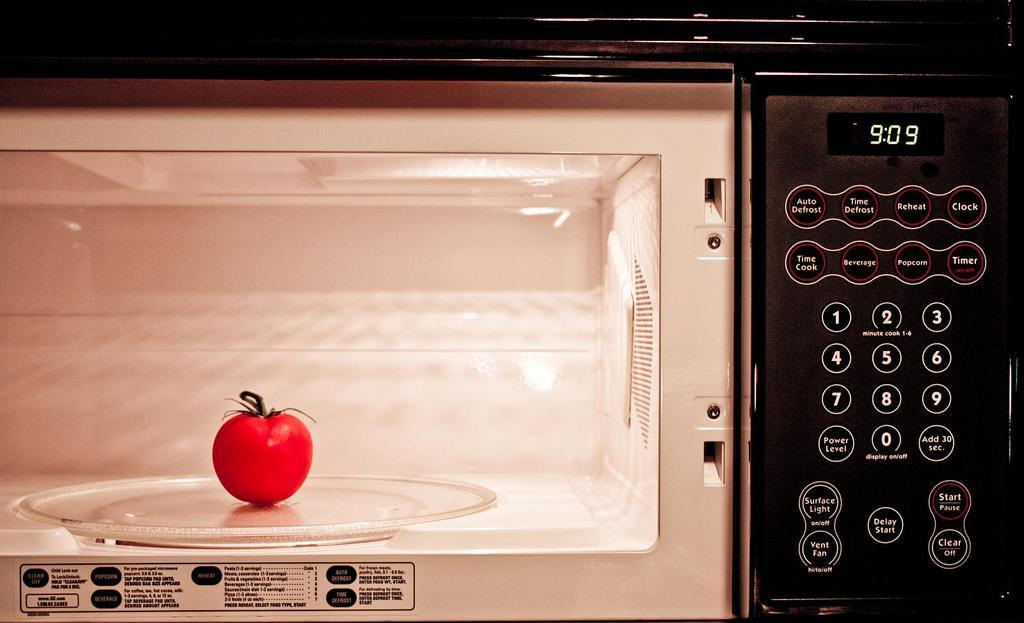Provide a one-sentence caption for the provided image. An apple in a microwave with 909 on the display. 